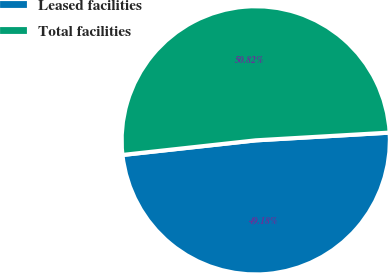Convert chart. <chart><loc_0><loc_0><loc_500><loc_500><pie_chart><fcel>Leased facilities<fcel>Total facilities<nl><fcel>49.18%<fcel>50.82%<nl></chart> 